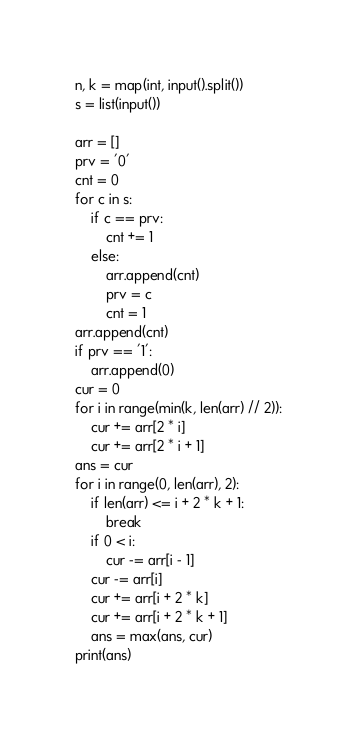<code> <loc_0><loc_0><loc_500><loc_500><_Python_>n, k = map(int, input().split())
s = list(input())

arr = []
prv = '0'
cnt = 0
for c in s:
    if c == prv:
        cnt += 1
    else:
        arr.append(cnt)
        prv = c
        cnt = 1
arr.append(cnt)
if prv == '1':
    arr.append(0)
cur = 0
for i in range(min(k, len(arr) // 2)):
    cur += arr[2 * i]
    cur += arr[2 * i + 1]
ans = cur
for i in range(0, len(arr), 2):
    if len(arr) <= i + 2 * k + 1:
        break
    if 0 < i:
        cur -= arr[i - 1]
    cur -= arr[i]
    cur += arr[i + 2 * k]
    cur += arr[i + 2 * k + 1]
    ans = max(ans, cur)
print(ans)</code> 